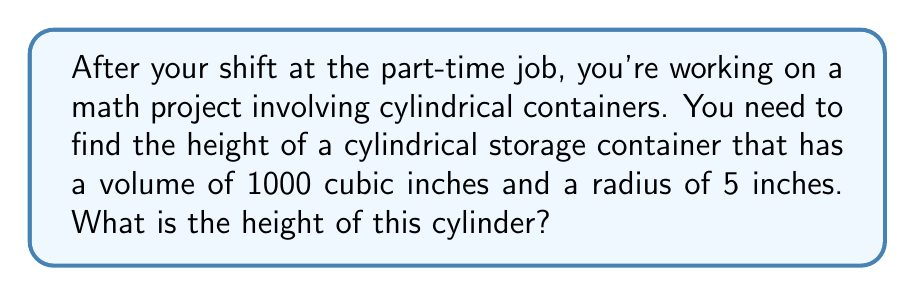Show me your answer to this math problem. Let's approach this step-by-step:

1) The formula for the volume of a cylinder is:
   $$V = \pi r^2 h$$
   where $V$ is volume, $r$ is radius, and $h$ is height.

2) We're given:
   $V = 1000$ cubic inches
   $r = 5$ inches

3) Let's substitute these values into the formula:
   $$1000 = \pi (5^2) h$$

4) Simplify the right side:
   $$1000 = 25\pi h$$

5) Now, we need to solve for $h$. Divide both sides by $25\pi$:
   $$\frac{1000}{25\pi} = h$$

6) Simplify:
   $$h = \frac{40}{\pi} \approx 12.73$$

Therefore, the height of the cylinder is approximately 12.73 inches.
Answer: $\frac{40}{\pi}$ inches or approximately 12.73 inches 